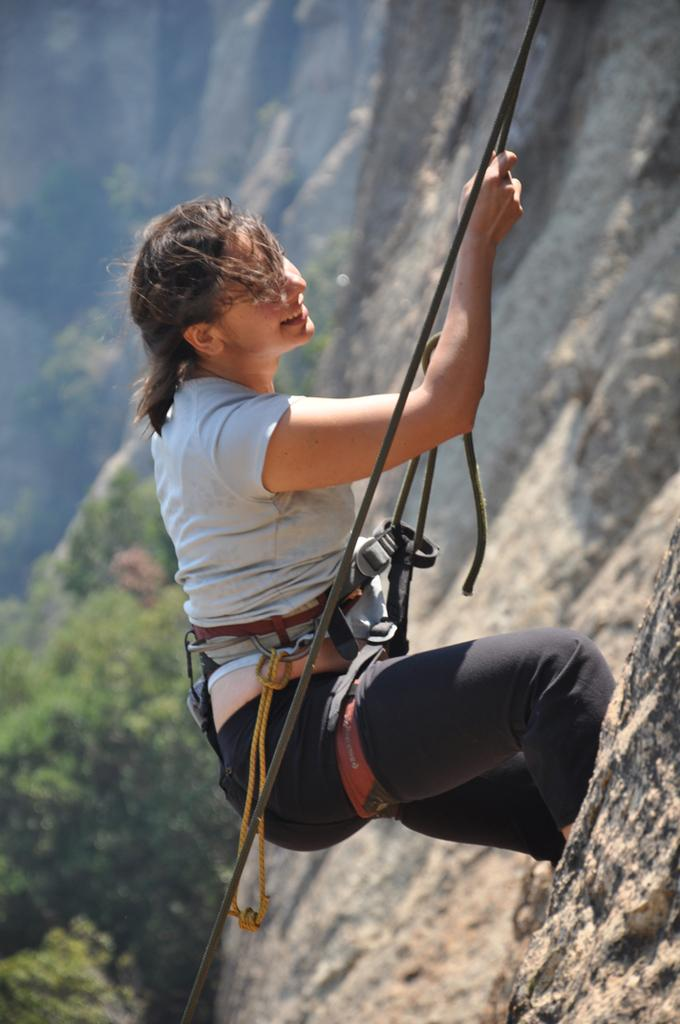Who is the main subject in the image? There is a girl in the image. What is the girl doing in the image? The girl is climbing a hill. What is the girl holding while climbing the hill? The girl is holding a rope. How is the rope attached to the girl? The rope is tied to the girl's belt. What can be seen in the background of the image? There are trees and stones in the background of the image. What type of flesh can be seen on the girl's hands in the image? There is no flesh visible on the girl's hands in the image; it is a photograph and does not show the internal structure of the girl's body. 